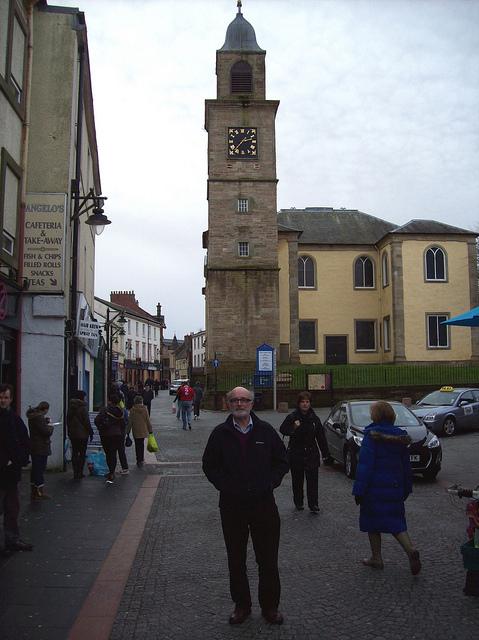Is it morning?
Be succinct. Yes. What surface the people walking on?
Short answer required. Asphalt. Is one of the men wearing a suit?
Keep it brief. No. What color is most prominent?
Be succinct. Blue. Is it daytime?
Keep it brief. Yes. Is it raining?
Give a very brief answer. No. What is everyone riding?
Keep it brief. Nothing. How many clocks are on the tower?
Concise answer only. 1. How many people in the picture?
Be succinct. 12. How many people are in this photo?
Answer briefly. 11. What are the ladies doing?
Give a very brief answer. Walking. What color is the man's shirt?
Concise answer only. Black. How many red shirts are there?
Keep it brief. 1. Is the man on his cell phone?
Quick response, please. No. Are all the cars parking in line?
Answer briefly. No. What color are the man's pants?
Give a very brief answer. Black. Is there a moped in the picture?
Concise answer only. No. What color is the woman's coat?
Concise answer only. Blue. What pattern is on the man's shirt?
Short answer required. Solid. Is this a proud moment?
Be succinct. Yes. How many floors the right building has?
Short answer required. 2. What is on the wall?
Concise answer only. Sign. How many people are visible?
Short answer required. 11. What print is on the mans coat?
Give a very brief answer. Logo. How many people are in the picture?
Quick response, please. 10. How many of these people are riding skateboards?
Write a very short answer. 0. What color is the building to the left of the photo?
Quick response, please. White. What color is the man's jacket?
Give a very brief answer. Black. Does the tower have a clock on it?
Quick response, please. Yes. Is the man a police officer?
Short answer required. No. How is driving the first car?
Answer briefly. Man. What time is it?
Short answer required. 7:05. What are the people holding?
Write a very short answer. Bags. Is that car parked?
Keep it brief. Yes. What car in on the road?
Quick response, please. Black car. Is there a bus in this picture?
Be succinct. No. How many arched windows are on the church?
Concise answer only. 3. Is the street busy?
Answer briefly. Yes. Is this a busy street?
Answer briefly. Yes. Are the people walking in the same direction?
Concise answer only. No. Are the people seated?
Write a very short answer. No. How many cabs are there?
Be succinct. 1. Is this man coming home from college?
Quick response, please. No. IS this in America?
Give a very brief answer. No. Is the man posing for a picture?
Keep it brief. Yes. Are they inside?
Concise answer only. No. Why the street is wet?
Short answer required. Rain. Is there a subway in this city?
Be succinct. No. 